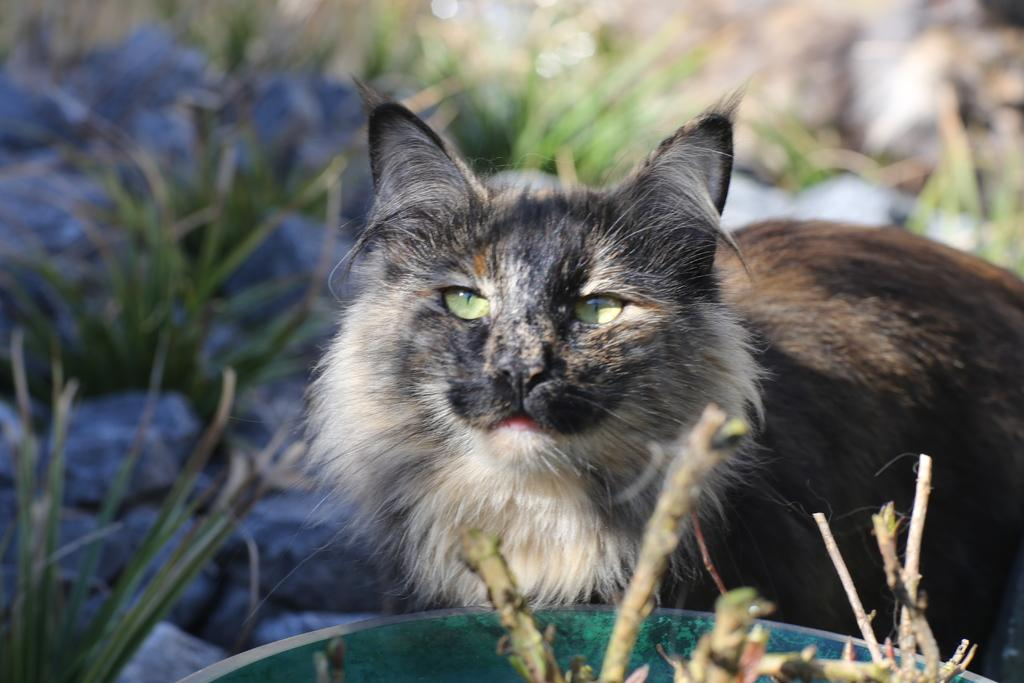What type of animal is in the image? There is a cat in the image. Where is the cat located in the image? The cat is on a surface. What is visible in the foreground of the image? There is a bowl and plants in the foreground of the image. What type of dress is the cat wearing in the image? Cats do not wear dresses, and there is no dress present in the image. 